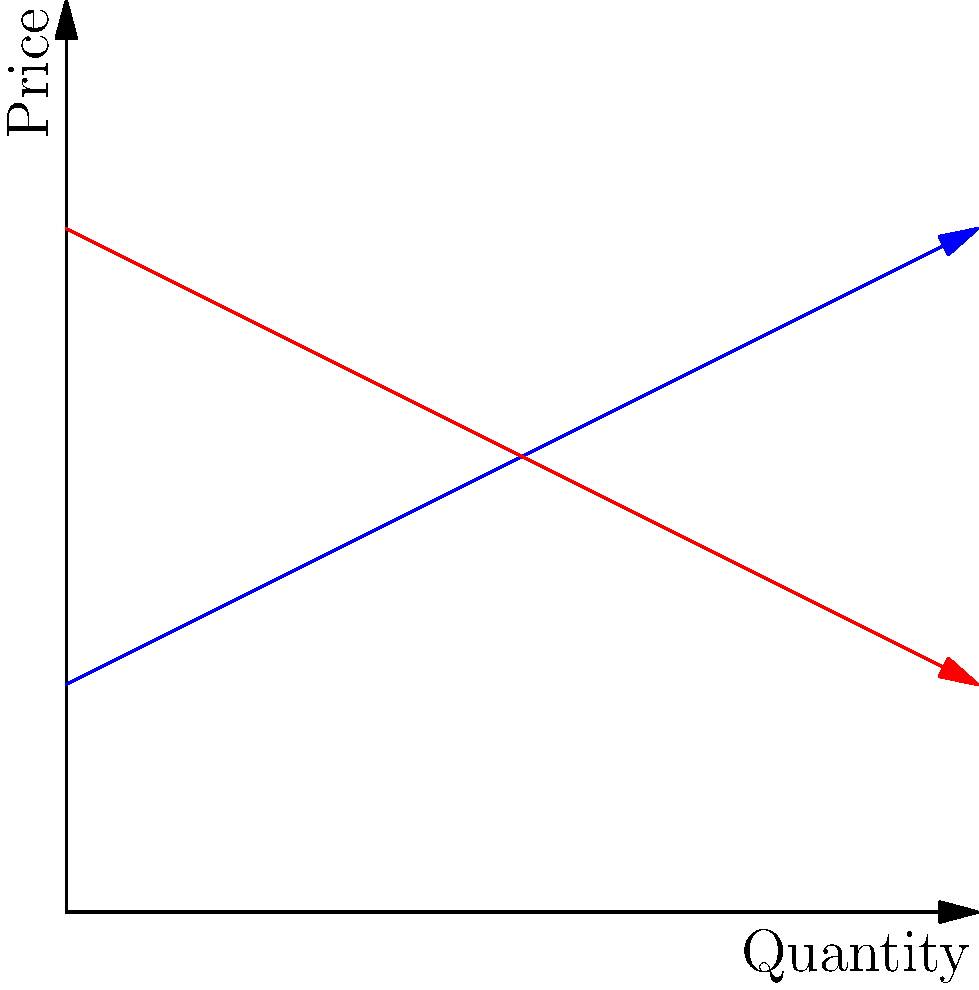In a regional trade agreement between two Latin American countries, the supply and demand curves for a certain commodity are given by $P_s = 5 + 0.5Q$ and $P_d = 15 - 0.5Q$, respectively, where $P$ is the price in dollars and $Q$ is the quantity in thousands of units. Calculate the equilibrium price and quantity, and determine the total revenue generated at equilibrium. To solve this problem, we'll follow these steps:

1) Find the equilibrium point by equating supply and demand:
   $P_s = P_d$
   $5 + 0.5Q = 15 - 0.5Q$

2) Solve for Q:
   $5 + 0.5Q = 15 - 0.5Q$
   $5 + 0.5Q + 0.5Q = 15$
   $5 + Q = 15$
   $Q = 10$

3) Find the equilibrium price by substituting Q = 10 into either equation:
   $P = 5 + 0.5(10) = 10$
   or
   $P = 15 - 0.5(10) = 10$

4) Calculate total revenue at equilibrium:
   Total Revenue = Price × Quantity
   $TR = 10 × 10 = 100$

Therefore, the equilibrium quantity is 10,000 units, the equilibrium price is $10, and the total revenue at equilibrium is $100,000.
Answer: Equilibrium: 10,000 units at $10; Total Revenue: $100,000 